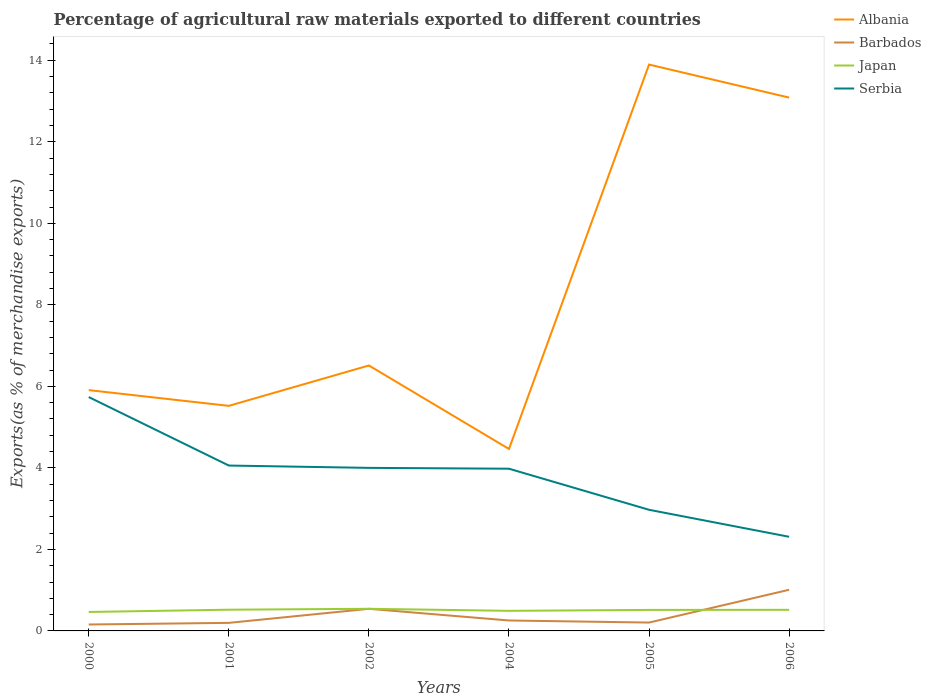Does the line corresponding to Barbados intersect with the line corresponding to Serbia?
Your answer should be compact. No. Is the number of lines equal to the number of legend labels?
Keep it short and to the point. Yes. Across all years, what is the maximum percentage of exports to different countries in Albania?
Provide a succinct answer. 4.46. In which year was the percentage of exports to different countries in Barbados maximum?
Make the answer very short. 2000. What is the total percentage of exports to different countries in Albania in the graph?
Offer a very short reply. -6.57. What is the difference between the highest and the second highest percentage of exports to different countries in Japan?
Your answer should be very brief. 0.08. How many lines are there?
Make the answer very short. 4. Are the values on the major ticks of Y-axis written in scientific E-notation?
Your answer should be compact. No. Does the graph contain any zero values?
Provide a succinct answer. No. Does the graph contain grids?
Provide a short and direct response. No. How are the legend labels stacked?
Provide a succinct answer. Vertical. What is the title of the graph?
Offer a very short reply. Percentage of agricultural raw materials exported to different countries. What is the label or title of the X-axis?
Keep it short and to the point. Years. What is the label or title of the Y-axis?
Make the answer very short. Exports(as % of merchandise exports). What is the Exports(as % of merchandise exports) in Albania in 2000?
Your response must be concise. 5.91. What is the Exports(as % of merchandise exports) in Barbados in 2000?
Keep it short and to the point. 0.16. What is the Exports(as % of merchandise exports) of Japan in 2000?
Ensure brevity in your answer.  0.46. What is the Exports(as % of merchandise exports) of Serbia in 2000?
Keep it short and to the point. 5.74. What is the Exports(as % of merchandise exports) of Albania in 2001?
Your response must be concise. 5.52. What is the Exports(as % of merchandise exports) of Barbados in 2001?
Provide a short and direct response. 0.2. What is the Exports(as % of merchandise exports) of Japan in 2001?
Your answer should be very brief. 0.52. What is the Exports(as % of merchandise exports) of Serbia in 2001?
Offer a terse response. 4.06. What is the Exports(as % of merchandise exports) of Albania in 2002?
Ensure brevity in your answer.  6.51. What is the Exports(as % of merchandise exports) of Barbados in 2002?
Your response must be concise. 0.54. What is the Exports(as % of merchandise exports) of Japan in 2002?
Give a very brief answer. 0.54. What is the Exports(as % of merchandise exports) in Serbia in 2002?
Your answer should be very brief. 4. What is the Exports(as % of merchandise exports) of Albania in 2004?
Keep it short and to the point. 4.46. What is the Exports(as % of merchandise exports) of Barbados in 2004?
Give a very brief answer. 0.26. What is the Exports(as % of merchandise exports) in Japan in 2004?
Offer a terse response. 0.49. What is the Exports(as % of merchandise exports) of Serbia in 2004?
Offer a very short reply. 3.98. What is the Exports(as % of merchandise exports) in Albania in 2005?
Ensure brevity in your answer.  13.89. What is the Exports(as % of merchandise exports) in Barbados in 2005?
Provide a succinct answer. 0.21. What is the Exports(as % of merchandise exports) of Japan in 2005?
Your response must be concise. 0.52. What is the Exports(as % of merchandise exports) of Serbia in 2005?
Your answer should be compact. 2.97. What is the Exports(as % of merchandise exports) of Albania in 2006?
Your answer should be very brief. 13.08. What is the Exports(as % of merchandise exports) of Barbados in 2006?
Your answer should be compact. 1.01. What is the Exports(as % of merchandise exports) of Japan in 2006?
Keep it short and to the point. 0.52. What is the Exports(as % of merchandise exports) of Serbia in 2006?
Give a very brief answer. 2.31. Across all years, what is the maximum Exports(as % of merchandise exports) in Albania?
Provide a succinct answer. 13.89. Across all years, what is the maximum Exports(as % of merchandise exports) of Barbados?
Your answer should be very brief. 1.01. Across all years, what is the maximum Exports(as % of merchandise exports) in Japan?
Your response must be concise. 0.54. Across all years, what is the maximum Exports(as % of merchandise exports) in Serbia?
Your answer should be compact. 5.74. Across all years, what is the minimum Exports(as % of merchandise exports) of Albania?
Keep it short and to the point. 4.46. Across all years, what is the minimum Exports(as % of merchandise exports) in Barbados?
Give a very brief answer. 0.16. Across all years, what is the minimum Exports(as % of merchandise exports) of Japan?
Give a very brief answer. 0.46. Across all years, what is the minimum Exports(as % of merchandise exports) in Serbia?
Your answer should be very brief. 2.31. What is the total Exports(as % of merchandise exports) of Albania in the graph?
Ensure brevity in your answer.  49.38. What is the total Exports(as % of merchandise exports) of Barbados in the graph?
Make the answer very short. 2.37. What is the total Exports(as % of merchandise exports) of Japan in the graph?
Keep it short and to the point. 3.05. What is the total Exports(as % of merchandise exports) of Serbia in the graph?
Offer a terse response. 23.05. What is the difference between the Exports(as % of merchandise exports) of Albania in 2000 and that in 2001?
Provide a short and direct response. 0.39. What is the difference between the Exports(as % of merchandise exports) in Barbados in 2000 and that in 2001?
Your response must be concise. -0.04. What is the difference between the Exports(as % of merchandise exports) of Japan in 2000 and that in 2001?
Your answer should be very brief. -0.06. What is the difference between the Exports(as % of merchandise exports) of Serbia in 2000 and that in 2001?
Offer a terse response. 1.68. What is the difference between the Exports(as % of merchandise exports) of Albania in 2000 and that in 2002?
Your answer should be very brief. -0.6. What is the difference between the Exports(as % of merchandise exports) in Barbados in 2000 and that in 2002?
Give a very brief answer. -0.38. What is the difference between the Exports(as % of merchandise exports) of Japan in 2000 and that in 2002?
Provide a short and direct response. -0.08. What is the difference between the Exports(as % of merchandise exports) of Serbia in 2000 and that in 2002?
Make the answer very short. 1.74. What is the difference between the Exports(as % of merchandise exports) of Albania in 2000 and that in 2004?
Your answer should be compact. 1.44. What is the difference between the Exports(as % of merchandise exports) of Barbados in 2000 and that in 2004?
Your answer should be very brief. -0.1. What is the difference between the Exports(as % of merchandise exports) of Japan in 2000 and that in 2004?
Keep it short and to the point. -0.03. What is the difference between the Exports(as % of merchandise exports) of Serbia in 2000 and that in 2004?
Offer a terse response. 1.76. What is the difference between the Exports(as % of merchandise exports) of Albania in 2000 and that in 2005?
Your answer should be compact. -7.99. What is the difference between the Exports(as % of merchandise exports) in Barbados in 2000 and that in 2005?
Your response must be concise. -0.05. What is the difference between the Exports(as % of merchandise exports) of Japan in 2000 and that in 2005?
Keep it short and to the point. -0.05. What is the difference between the Exports(as % of merchandise exports) of Serbia in 2000 and that in 2005?
Offer a terse response. 2.77. What is the difference between the Exports(as % of merchandise exports) in Albania in 2000 and that in 2006?
Provide a short and direct response. -7.18. What is the difference between the Exports(as % of merchandise exports) of Barbados in 2000 and that in 2006?
Offer a very short reply. -0.85. What is the difference between the Exports(as % of merchandise exports) of Japan in 2000 and that in 2006?
Give a very brief answer. -0.05. What is the difference between the Exports(as % of merchandise exports) in Serbia in 2000 and that in 2006?
Your response must be concise. 3.43. What is the difference between the Exports(as % of merchandise exports) in Albania in 2001 and that in 2002?
Your answer should be compact. -0.99. What is the difference between the Exports(as % of merchandise exports) in Barbados in 2001 and that in 2002?
Make the answer very short. -0.34. What is the difference between the Exports(as % of merchandise exports) in Japan in 2001 and that in 2002?
Your answer should be very brief. -0.02. What is the difference between the Exports(as % of merchandise exports) in Serbia in 2001 and that in 2002?
Provide a succinct answer. 0.06. What is the difference between the Exports(as % of merchandise exports) in Albania in 2001 and that in 2004?
Give a very brief answer. 1.06. What is the difference between the Exports(as % of merchandise exports) of Barbados in 2001 and that in 2004?
Keep it short and to the point. -0.06. What is the difference between the Exports(as % of merchandise exports) in Japan in 2001 and that in 2004?
Your answer should be compact. 0.03. What is the difference between the Exports(as % of merchandise exports) in Serbia in 2001 and that in 2004?
Your answer should be compact. 0.08. What is the difference between the Exports(as % of merchandise exports) of Albania in 2001 and that in 2005?
Provide a succinct answer. -8.37. What is the difference between the Exports(as % of merchandise exports) of Barbados in 2001 and that in 2005?
Give a very brief answer. -0.01. What is the difference between the Exports(as % of merchandise exports) of Japan in 2001 and that in 2005?
Your answer should be compact. 0.01. What is the difference between the Exports(as % of merchandise exports) in Serbia in 2001 and that in 2005?
Ensure brevity in your answer.  1.09. What is the difference between the Exports(as % of merchandise exports) of Albania in 2001 and that in 2006?
Offer a terse response. -7.56. What is the difference between the Exports(as % of merchandise exports) in Barbados in 2001 and that in 2006?
Keep it short and to the point. -0.81. What is the difference between the Exports(as % of merchandise exports) of Japan in 2001 and that in 2006?
Offer a very short reply. 0. What is the difference between the Exports(as % of merchandise exports) in Serbia in 2001 and that in 2006?
Your answer should be very brief. 1.75. What is the difference between the Exports(as % of merchandise exports) in Albania in 2002 and that in 2004?
Give a very brief answer. 2.05. What is the difference between the Exports(as % of merchandise exports) in Barbados in 2002 and that in 2004?
Your answer should be compact. 0.29. What is the difference between the Exports(as % of merchandise exports) of Japan in 2002 and that in 2004?
Offer a very short reply. 0.05. What is the difference between the Exports(as % of merchandise exports) in Serbia in 2002 and that in 2004?
Give a very brief answer. 0.02. What is the difference between the Exports(as % of merchandise exports) in Albania in 2002 and that in 2005?
Your response must be concise. -7.38. What is the difference between the Exports(as % of merchandise exports) of Barbados in 2002 and that in 2005?
Make the answer very short. 0.34. What is the difference between the Exports(as % of merchandise exports) in Japan in 2002 and that in 2005?
Your answer should be compact. 0.03. What is the difference between the Exports(as % of merchandise exports) of Serbia in 2002 and that in 2005?
Your answer should be compact. 1.03. What is the difference between the Exports(as % of merchandise exports) of Albania in 2002 and that in 2006?
Offer a terse response. -6.57. What is the difference between the Exports(as % of merchandise exports) in Barbados in 2002 and that in 2006?
Offer a terse response. -0.47. What is the difference between the Exports(as % of merchandise exports) in Japan in 2002 and that in 2006?
Your answer should be very brief. 0.02. What is the difference between the Exports(as % of merchandise exports) in Serbia in 2002 and that in 2006?
Offer a very short reply. 1.69. What is the difference between the Exports(as % of merchandise exports) in Albania in 2004 and that in 2005?
Give a very brief answer. -9.43. What is the difference between the Exports(as % of merchandise exports) of Barbados in 2004 and that in 2005?
Keep it short and to the point. 0.05. What is the difference between the Exports(as % of merchandise exports) in Japan in 2004 and that in 2005?
Provide a short and direct response. -0.02. What is the difference between the Exports(as % of merchandise exports) in Serbia in 2004 and that in 2005?
Your response must be concise. 1.01. What is the difference between the Exports(as % of merchandise exports) in Albania in 2004 and that in 2006?
Give a very brief answer. -8.62. What is the difference between the Exports(as % of merchandise exports) in Barbados in 2004 and that in 2006?
Give a very brief answer. -0.75. What is the difference between the Exports(as % of merchandise exports) of Japan in 2004 and that in 2006?
Offer a terse response. -0.03. What is the difference between the Exports(as % of merchandise exports) of Serbia in 2004 and that in 2006?
Keep it short and to the point. 1.67. What is the difference between the Exports(as % of merchandise exports) in Albania in 2005 and that in 2006?
Your answer should be compact. 0.81. What is the difference between the Exports(as % of merchandise exports) of Barbados in 2005 and that in 2006?
Ensure brevity in your answer.  -0.8. What is the difference between the Exports(as % of merchandise exports) of Japan in 2005 and that in 2006?
Your answer should be very brief. -0. What is the difference between the Exports(as % of merchandise exports) in Serbia in 2005 and that in 2006?
Your response must be concise. 0.66. What is the difference between the Exports(as % of merchandise exports) in Albania in 2000 and the Exports(as % of merchandise exports) in Barbados in 2001?
Make the answer very short. 5.71. What is the difference between the Exports(as % of merchandise exports) in Albania in 2000 and the Exports(as % of merchandise exports) in Japan in 2001?
Ensure brevity in your answer.  5.39. What is the difference between the Exports(as % of merchandise exports) in Albania in 2000 and the Exports(as % of merchandise exports) in Serbia in 2001?
Your answer should be compact. 1.85. What is the difference between the Exports(as % of merchandise exports) in Barbados in 2000 and the Exports(as % of merchandise exports) in Japan in 2001?
Offer a terse response. -0.36. What is the difference between the Exports(as % of merchandise exports) in Barbados in 2000 and the Exports(as % of merchandise exports) in Serbia in 2001?
Offer a very short reply. -3.9. What is the difference between the Exports(as % of merchandise exports) in Japan in 2000 and the Exports(as % of merchandise exports) in Serbia in 2001?
Your answer should be compact. -3.59. What is the difference between the Exports(as % of merchandise exports) of Albania in 2000 and the Exports(as % of merchandise exports) of Barbados in 2002?
Provide a short and direct response. 5.37. What is the difference between the Exports(as % of merchandise exports) of Albania in 2000 and the Exports(as % of merchandise exports) of Japan in 2002?
Ensure brevity in your answer.  5.36. What is the difference between the Exports(as % of merchandise exports) in Albania in 2000 and the Exports(as % of merchandise exports) in Serbia in 2002?
Ensure brevity in your answer.  1.91. What is the difference between the Exports(as % of merchandise exports) of Barbados in 2000 and the Exports(as % of merchandise exports) of Japan in 2002?
Ensure brevity in your answer.  -0.39. What is the difference between the Exports(as % of merchandise exports) of Barbados in 2000 and the Exports(as % of merchandise exports) of Serbia in 2002?
Offer a very short reply. -3.84. What is the difference between the Exports(as % of merchandise exports) in Japan in 2000 and the Exports(as % of merchandise exports) in Serbia in 2002?
Ensure brevity in your answer.  -3.54. What is the difference between the Exports(as % of merchandise exports) of Albania in 2000 and the Exports(as % of merchandise exports) of Barbados in 2004?
Your response must be concise. 5.65. What is the difference between the Exports(as % of merchandise exports) in Albania in 2000 and the Exports(as % of merchandise exports) in Japan in 2004?
Give a very brief answer. 5.41. What is the difference between the Exports(as % of merchandise exports) of Albania in 2000 and the Exports(as % of merchandise exports) of Serbia in 2004?
Provide a short and direct response. 1.93. What is the difference between the Exports(as % of merchandise exports) of Barbados in 2000 and the Exports(as % of merchandise exports) of Japan in 2004?
Make the answer very short. -0.34. What is the difference between the Exports(as % of merchandise exports) of Barbados in 2000 and the Exports(as % of merchandise exports) of Serbia in 2004?
Keep it short and to the point. -3.82. What is the difference between the Exports(as % of merchandise exports) in Japan in 2000 and the Exports(as % of merchandise exports) in Serbia in 2004?
Your answer should be compact. -3.51. What is the difference between the Exports(as % of merchandise exports) in Albania in 2000 and the Exports(as % of merchandise exports) in Barbados in 2005?
Offer a terse response. 5.7. What is the difference between the Exports(as % of merchandise exports) of Albania in 2000 and the Exports(as % of merchandise exports) of Japan in 2005?
Offer a terse response. 5.39. What is the difference between the Exports(as % of merchandise exports) of Albania in 2000 and the Exports(as % of merchandise exports) of Serbia in 2005?
Your response must be concise. 2.94. What is the difference between the Exports(as % of merchandise exports) in Barbados in 2000 and the Exports(as % of merchandise exports) in Japan in 2005?
Provide a short and direct response. -0.36. What is the difference between the Exports(as % of merchandise exports) of Barbados in 2000 and the Exports(as % of merchandise exports) of Serbia in 2005?
Your answer should be compact. -2.81. What is the difference between the Exports(as % of merchandise exports) in Japan in 2000 and the Exports(as % of merchandise exports) in Serbia in 2005?
Offer a terse response. -2.51. What is the difference between the Exports(as % of merchandise exports) in Albania in 2000 and the Exports(as % of merchandise exports) in Barbados in 2006?
Provide a short and direct response. 4.9. What is the difference between the Exports(as % of merchandise exports) of Albania in 2000 and the Exports(as % of merchandise exports) of Japan in 2006?
Your answer should be compact. 5.39. What is the difference between the Exports(as % of merchandise exports) of Albania in 2000 and the Exports(as % of merchandise exports) of Serbia in 2006?
Offer a very short reply. 3.6. What is the difference between the Exports(as % of merchandise exports) in Barbados in 2000 and the Exports(as % of merchandise exports) in Japan in 2006?
Make the answer very short. -0.36. What is the difference between the Exports(as % of merchandise exports) in Barbados in 2000 and the Exports(as % of merchandise exports) in Serbia in 2006?
Offer a very short reply. -2.15. What is the difference between the Exports(as % of merchandise exports) of Japan in 2000 and the Exports(as % of merchandise exports) of Serbia in 2006?
Keep it short and to the point. -1.84. What is the difference between the Exports(as % of merchandise exports) in Albania in 2001 and the Exports(as % of merchandise exports) in Barbados in 2002?
Your answer should be very brief. 4.98. What is the difference between the Exports(as % of merchandise exports) in Albania in 2001 and the Exports(as % of merchandise exports) in Japan in 2002?
Offer a very short reply. 4.98. What is the difference between the Exports(as % of merchandise exports) of Albania in 2001 and the Exports(as % of merchandise exports) of Serbia in 2002?
Provide a succinct answer. 1.52. What is the difference between the Exports(as % of merchandise exports) of Barbados in 2001 and the Exports(as % of merchandise exports) of Japan in 2002?
Your response must be concise. -0.34. What is the difference between the Exports(as % of merchandise exports) in Barbados in 2001 and the Exports(as % of merchandise exports) in Serbia in 2002?
Your answer should be very brief. -3.8. What is the difference between the Exports(as % of merchandise exports) of Japan in 2001 and the Exports(as % of merchandise exports) of Serbia in 2002?
Your answer should be compact. -3.48. What is the difference between the Exports(as % of merchandise exports) in Albania in 2001 and the Exports(as % of merchandise exports) in Barbados in 2004?
Make the answer very short. 5.27. What is the difference between the Exports(as % of merchandise exports) in Albania in 2001 and the Exports(as % of merchandise exports) in Japan in 2004?
Your response must be concise. 5.03. What is the difference between the Exports(as % of merchandise exports) of Albania in 2001 and the Exports(as % of merchandise exports) of Serbia in 2004?
Offer a very short reply. 1.54. What is the difference between the Exports(as % of merchandise exports) of Barbados in 2001 and the Exports(as % of merchandise exports) of Japan in 2004?
Offer a terse response. -0.3. What is the difference between the Exports(as % of merchandise exports) of Barbados in 2001 and the Exports(as % of merchandise exports) of Serbia in 2004?
Provide a short and direct response. -3.78. What is the difference between the Exports(as % of merchandise exports) of Japan in 2001 and the Exports(as % of merchandise exports) of Serbia in 2004?
Provide a succinct answer. -3.46. What is the difference between the Exports(as % of merchandise exports) in Albania in 2001 and the Exports(as % of merchandise exports) in Barbados in 2005?
Offer a terse response. 5.32. What is the difference between the Exports(as % of merchandise exports) of Albania in 2001 and the Exports(as % of merchandise exports) of Japan in 2005?
Provide a short and direct response. 5.01. What is the difference between the Exports(as % of merchandise exports) in Albania in 2001 and the Exports(as % of merchandise exports) in Serbia in 2005?
Your answer should be compact. 2.55. What is the difference between the Exports(as % of merchandise exports) of Barbados in 2001 and the Exports(as % of merchandise exports) of Japan in 2005?
Your answer should be compact. -0.32. What is the difference between the Exports(as % of merchandise exports) in Barbados in 2001 and the Exports(as % of merchandise exports) in Serbia in 2005?
Keep it short and to the point. -2.77. What is the difference between the Exports(as % of merchandise exports) of Japan in 2001 and the Exports(as % of merchandise exports) of Serbia in 2005?
Provide a short and direct response. -2.45. What is the difference between the Exports(as % of merchandise exports) of Albania in 2001 and the Exports(as % of merchandise exports) of Barbados in 2006?
Provide a succinct answer. 4.51. What is the difference between the Exports(as % of merchandise exports) of Albania in 2001 and the Exports(as % of merchandise exports) of Japan in 2006?
Keep it short and to the point. 5. What is the difference between the Exports(as % of merchandise exports) in Albania in 2001 and the Exports(as % of merchandise exports) in Serbia in 2006?
Offer a very short reply. 3.21. What is the difference between the Exports(as % of merchandise exports) in Barbados in 2001 and the Exports(as % of merchandise exports) in Japan in 2006?
Offer a very short reply. -0.32. What is the difference between the Exports(as % of merchandise exports) in Barbados in 2001 and the Exports(as % of merchandise exports) in Serbia in 2006?
Your answer should be compact. -2.11. What is the difference between the Exports(as % of merchandise exports) in Japan in 2001 and the Exports(as % of merchandise exports) in Serbia in 2006?
Offer a terse response. -1.79. What is the difference between the Exports(as % of merchandise exports) of Albania in 2002 and the Exports(as % of merchandise exports) of Barbados in 2004?
Keep it short and to the point. 6.26. What is the difference between the Exports(as % of merchandise exports) in Albania in 2002 and the Exports(as % of merchandise exports) in Japan in 2004?
Your response must be concise. 6.02. What is the difference between the Exports(as % of merchandise exports) in Albania in 2002 and the Exports(as % of merchandise exports) in Serbia in 2004?
Offer a very short reply. 2.53. What is the difference between the Exports(as % of merchandise exports) in Barbados in 2002 and the Exports(as % of merchandise exports) in Japan in 2004?
Provide a short and direct response. 0.05. What is the difference between the Exports(as % of merchandise exports) in Barbados in 2002 and the Exports(as % of merchandise exports) in Serbia in 2004?
Provide a short and direct response. -3.44. What is the difference between the Exports(as % of merchandise exports) in Japan in 2002 and the Exports(as % of merchandise exports) in Serbia in 2004?
Provide a succinct answer. -3.44. What is the difference between the Exports(as % of merchandise exports) of Albania in 2002 and the Exports(as % of merchandise exports) of Barbados in 2005?
Provide a succinct answer. 6.31. What is the difference between the Exports(as % of merchandise exports) in Albania in 2002 and the Exports(as % of merchandise exports) in Japan in 2005?
Make the answer very short. 6. What is the difference between the Exports(as % of merchandise exports) of Albania in 2002 and the Exports(as % of merchandise exports) of Serbia in 2005?
Your answer should be very brief. 3.54. What is the difference between the Exports(as % of merchandise exports) of Barbados in 2002 and the Exports(as % of merchandise exports) of Japan in 2005?
Your answer should be compact. 0.03. What is the difference between the Exports(as % of merchandise exports) in Barbados in 2002 and the Exports(as % of merchandise exports) in Serbia in 2005?
Offer a terse response. -2.43. What is the difference between the Exports(as % of merchandise exports) in Japan in 2002 and the Exports(as % of merchandise exports) in Serbia in 2005?
Your response must be concise. -2.43. What is the difference between the Exports(as % of merchandise exports) in Albania in 2002 and the Exports(as % of merchandise exports) in Barbados in 2006?
Provide a short and direct response. 5.5. What is the difference between the Exports(as % of merchandise exports) in Albania in 2002 and the Exports(as % of merchandise exports) in Japan in 2006?
Offer a terse response. 5.99. What is the difference between the Exports(as % of merchandise exports) of Albania in 2002 and the Exports(as % of merchandise exports) of Serbia in 2006?
Offer a very short reply. 4.2. What is the difference between the Exports(as % of merchandise exports) of Barbados in 2002 and the Exports(as % of merchandise exports) of Japan in 2006?
Provide a succinct answer. 0.02. What is the difference between the Exports(as % of merchandise exports) of Barbados in 2002 and the Exports(as % of merchandise exports) of Serbia in 2006?
Give a very brief answer. -1.77. What is the difference between the Exports(as % of merchandise exports) in Japan in 2002 and the Exports(as % of merchandise exports) in Serbia in 2006?
Your response must be concise. -1.77. What is the difference between the Exports(as % of merchandise exports) in Albania in 2004 and the Exports(as % of merchandise exports) in Barbados in 2005?
Your answer should be very brief. 4.26. What is the difference between the Exports(as % of merchandise exports) of Albania in 2004 and the Exports(as % of merchandise exports) of Japan in 2005?
Provide a short and direct response. 3.95. What is the difference between the Exports(as % of merchandise exports) of Albania in 2004 and the Exports(as % of merchandise exports) of Serbia in 2005?
Offer a very short reply. 1.49. What is the difference between the Exports(as % of merchandise exports) in Barbados in 2004 and the Exports(as % of merchandise exports) in Japan in 2005?
Ensure brevity in your answer.  -0.26. What is the difference between the Exports(as % of merchandise exports) in Barbados in 2004 and the Exports(as % of merchandise exports) in Serbia in 2005?
Your answer should be compact. -2.72. What is the difference between the Exports(as % of merchandise exports) of Japan in 2004 and the Exports(as % of merchandise exports) of Serbia in 2005?
Offer a very short reply. -2.48. What is the difference between the Exports(as % of merchandise exports) of Albania in 2004 and the Exports(as % of merchandise exports) of Barbados in 2006?
Ensure brevity in your answer.  3.45. What is the difference between the Exports(as % of merchandise exports) of Albania in 2004 and the Exports(as % of merchandise exports) of Japan in 2006?
Provide a succinct answer. 3.95. What is the difference between the Exports(as % of merchandise exports) in Albania in 2004 and the Exports(as % of merchandise exports) in Serbia in 2006?
Give a very brief answer. 2.15. What is the difference between the Exports(as % of merchandise exports) of Barbados in 2004 and the Exports(as % of merchandise exports) of Japan in 2006?
Your answer should be compact. -0.26. What is the difference between the Exports(as % of merchandise exports) in Barbados in 2004 and the Exports(as % of merchandise exports) in Serbia in 2006?
Provide a short and direct response. -2.05. What is the difference between the Exports(as % of merchandise exports) of Japan in 2004 and the Exports(as % of merchandise exports) of Serbia in 2006?
Ensure brevity in your answer.  -1.82. What is the difference between the Exports(as % of merchandise exports) of Albania in 2005 and the Exports(as % of merchandise exports) of Barbados in 2006?
Offer a terse response. 12.88. What is the difference between the Exports(as % of merchandise exports) of Albania in 2005 and the Exports(as % of merchandise exports) of Japan in 2006?
Make the answer very short. 13.38. What is the difference between the Exports(as % of merchandise exports) of Albania in 2005 and the Exports(as % of merchandise exports) of Serbia in 2006?
Provide a short and direct response. 11.58. What is the difference between the Exports(as % of merchandise exports) of Barbados in 2005 and the Exports(as % of merchandise exports) of Japan in 2006?
Keep it short and to the point. -0.31. What is the difference between the Exports(as % of merchandise exports) of Barbados in 2005 and the Exports(as % of merchandise exports) of Serbia in 2006?
Keep it short and to the point. -2.1. What is the difference between the Exports(as % of merchandise exports) of Japan in 2005 and the Exports(as % of merchandise exports) of Serbia in 2006?
Ensure brevity in your answer.  -1.79. What is the average Exports(as % of merchandise exports) in Albania per year?
Make the answer very short. 8.23. What is the average Exports(as % of merchandise exports) of Barbados per year?
Give a very brief answer. 0.39. What is the average Exports(as % of merchandise exports) of Japan per year?
Your response must be concise. 0.51. What is the average Exports(as % of merchandise exports) of Serbia per year?
Give a very brief answer. 3.84. In the year 2000, what is the difference between the Exports(as % of merchandise exports) in Albania and Exports(as % of merchandise exports) in Barbados?
Your answer should be compact. 5.75. In the year 2000, what is the difference between the Exports(as % of merchandise exports) in Albania and Exports(as % of merchandise exports) in Japan?
Make the answer very short. 5.44. In the year 2000, what is the difference between the Exports(as % of merchandise exports) in Albania and Exports(as % of merchandise exports) in Serbia?
Provide a succinct answer. 0.17. In the year 2000, what is the difference between the Exports(as % of merchandise exports) in Barbados and Exports(as % of merchandise exports) in Japan?
Your response must be concise. -0.31. In the year 2000, what is the difference between the Exports(as % of merchandise exports) in Barbados and Exports(as % of merchandise exports) in Serbia?
Provide a succinct answer. -5.58. In the year 2000, what is the difference between the Exports(as % of merchandise exports) in Japan and Exports(as % of merchandise exports) in Serbia?
Make the answer very short. -5.27. In the year 2001, what is the difference between the Exports(as % of merchandise exports) in Albania and Exports(as % of merchandise exports) in Barbados?
Provide a short and direct response. 5.32. In the year 2001, what is the difference between the Exports(as % of merchandise exports) of Albania and Exports(as % of merchandise exports) of Japan?
Your response must be concise. 5. In the year 2001, what is the difference between the Exports(as % of merchandise exports) in Albania and Exports(as % of merchandise exports) in Serbia?
Offer a terse response. 1.46. In the year 2001, what is the difference between the Exports(as % of merchandise exports) in Barbados and Exports(as % of merchandise exports) in Japan?
Offer a very short reply. -0.32. In the year 2001, what is the difference between the Exports(as % of merchandise exports) of Barbados and Exports(as % of merchandise exports) of Serbia?
Your response must be concise. -3.86. In the year 2001, what is the difference between the Exports(as % of merchandise exports) in Japan and Exports(as % of merchandise exports) in Serbia?
Ensure brevity in your answer.  -3.54. In the year 2002, what is the difference between the Exports(as % of merchandise exports) of Albania and Exports(as % of merchandise exports) of Barbados?
Ensure brevity in your answer.  5.97. In the year 2002, what is the difference between the Exports(as % of merchandise exports) of Albania and Exports(as % of merchandise exports) of Japan?
Offer a very short reply. 5.97. In the year 2002, what is the difference between the Exports(as % of merchandise exports) in Albania and Exports(as % of merchandise exports) in Serbia?
Ensure brevity in your answer.  2.51. In the year 2002, what is the difference between the Exports(as % of merchandise exports) of Barbados and Exports(as % of merchandise exports) of Japan?
Provide a succinct answer. -0. In the year 2002, what is the difference between the Exports(as % of merchandise exports) in Barbados and Exports(as % of merchandise exports) in Serbia?
Offer a very short reply. -3.46. In the year 2002, what is the difference between the Exports(as % of merchandise exports) in Japan and Exports(as % of merchandise exports) in Serbia?
Your answer should be compact. -3.46. In the year 2004, what is the difference between the Exports(as % of merchandise exports) in Albania and Exports(as % of merchandise exports) in Barbados?
Offer a very short reply. 4.21. In the year 2004, what is the difference between the Exports(as % of merchandise exports) in Albania and Exports(as % of merchandise exports) in Japan?
Ensure brevity in your answer.  3.97. In the year 2004, what is the difference between the Exports(as % of merchandise exports) of Albania and Exports(as % of merchandise exports) of Serbia?
Provide a succinct answer. 0.48. In the year 2004, what is the difference between the Exports(as % of merchandise exports) in Barbados and Exports(as % of merchandise exports) in Japan?
Ensure brevity in your answer.  -0.24. In the year 2004, what is the difference between the Exports(as % of merchandise exports) of Barbados and Exports(as % of merchandise exports) of Serbia?
Provide a succinct answer. -3.72. In the year 2004, what is the difference between the Exports(as % of merchandise exports) in Japan and Exports(as % of merchandise exports) in Serbia?
Provide a succinct answer. -3.49. In the year 2005, what is the difference between the Exports(as % of merchandise exports) in Albania and Exports(as % of merchandise exports) in Barbados?
Offer a terse response. 13.69. In the year 2005, what is the difference between the Exports(as % of merchandise exports) in Albania and Exports(as % of merchandise exports) in Japan?
Your response must be concise. 13.38. In the year 2005, what is the difference between the Exports(as % of merchandise exports) of Albania and Exports(as % of merchandise exports) of Serbia?
Your answer should be very brief. 10.92. In the year 2005, what is the difference between the Exports(as % of merchandise exports) of Barbados and Exports(as % of merchandise exports) of Japan?
Ensure brevity in your answer.  -0.31. In the year 2005, what is the difference between the Exports(as % of merchandise exports) in Barbados and Exports(as % of merchandise exports) in Serbia?
Provide a short and direct response. -2.77. In the year 2005, what is the difference between the Exports(as % of merchandise exports) in Japan and Exports(as % of merchandise exports) in Serbia?
Your answer should be compact. -2.46. In the year 2006, what is the difference between the Exports(as % of merchandise exports) in Albania and Exports(as % of merchandise exports) in Barbados?
Make the answer very short. 12.07. In the year 2006, what is the difference between the Exports(as % of merchandise exports) in Albania and Exports(as % of merchandise exports) in Japan?
Offer a very short reply. 12.57. In the year 2006, what is the difference between the Exports(as % of merchandise exports) of Albania and Exports(as % of merchandise exports) of Serbia?
Provide a succinct answer. 10.77. In the year 2006, what is the difference between the Exports(as % of merchandise exports) of Barbados and Exports(as % of merchandise exports) of Japan?
Your answer should be very brief. 0.49. In the year 2006, what is the difference between the Exports(as % of merchandise exports) in Barbados and Exports(as % of merchandise exports) in Serbia?
Provide a short and direct response. -1.3. In the year 2006, what is the difference between the Exports(as % of merchandise exports) of Japan and Exports(as % of merchandise exports) of Serbia?
Provide a succinct answer. -1.79. What is the ratio of the Exports(as % of merchandise exports) of Albania in 2000 to that in 2001?
Make the answer very short. 1.07. What is the ratio of the Exports(as % of merchandise exports) in Barbados in 2000 to that in 2001?
Offer a very short reply. 0.8. What is the ratio of the Exports(as % of merchandise exports) in Japan in 2000 to that in 2001?
Your answer should be compact. 0.89. What is the ratio of the Exports(as % of merchandise exports) of Serbia in 2000 to that in 2001?
Provide a short and direct response. 1.41. What is the ratio of the Exports(as % of merchandise exports) in Albania in 2000 to that in 2002?
Provide a short and direct response. 0.91. What is the ratio of the Exports(as % of merchandise exports) in Barbados in 2000 to that in 2002?
Your answer should be very brief. 0.29. What is the ratio of the Exports(as % of merchandise exports) of Japan in 2000 to that in 2002?
Ensure brevity in your answer.  0.86. What is the ratio of the Exports(as % of merchandise exports) in Serbia in 2000 to that in 2002?
Make the answer very short. 1.43. What is the ratio of the Exports(as % of merchandise exports) of Albania in 2000 to that in 2004?
Give a very brief answer. 1.32. What is the ratio of the Exports(as % of merchandise exports) in Barbados in 2000 to that in 2004?
Give a very brief answer. 0.61. What is the ratio of the Exports(as % of merchandise exports) of Japan in 2000 to that in 2004?
Keep it short and to the point. 0.94. What is the ratio of the Exports(as % of merchandise exports) in Serbia in 2000 to that in 2004?
Give a very brief answer. 1.44. What is the ratio of the Exports(as % of merchandise exports) in Albania in 2000 to that in 2005?
Offer a very short reply. 0.43. What is the ratio of the Exports(as % of merchandise exports) in Barbados in 2000 to that in 2005?
Provide a succinct answer. 0.77. What is the ratio of the Exports(as % of merchandise exports) in Japan in 2000 to that in 2005?
Offer a very short reply. 0.9. What is the ratio of the Exports(as % of merchandise exports) of Serbia in 2000 to that in 2005?
Keep it short and to the point. 1.93. What is the ratio of the Exports(as % of merchandise exports) in Albania in 2000 to that in 2006?
Make the answer very short. 0.45. What is the ratio of the Exports(as % of merchandise exports) of Barbados in 2000 to that in 2006?
Your answer should be very brief. 0.16. What is the ratio of the Exports(as % of merchandise exports) in Japan in 2000 to that in 2006?
Provide a short and direct response. 0.9. What is the ratio of the Exports(as % of merchandise exports) of Serbia in 2000 to that in 2006?
Offer a very short reply. 2.48. What is the ratio of the Exports(as % of merchandise exports) of Albania in 2001 to that in 2002?
Keep it short and to the point. 0.85. What is the ratio of the Exports(as % of merchandise exports) in Barbados in 2001 to that in 2002?
Ensure brevity in your answer.  0.36. What is the ratio of the Exports(as % of merchandise exports) of Japan in 2001 to that in 2002?
Keep it short and to the point. 0.96. What is the ratio of the Exports(as % of merchandise exports) in Serbia in 2001 to that in 2002?
Keep it short and to the point. 1.01. What is the ratio of the Exports(as % of merchandise exports) in Albania in 2001 to that in 2004?
Give a very brief answer. 1.24. What is the ratio of the Exports(as % of merchandise exports) in Barbados in 2001 to that in 2004?
Provide a short and direct response. 0.77. What is the ratio of the Exports(as % of merchandise exports) of Japan in 2001 to that in 2004?
Offer a very short reply. 1.06. What is the ratio of the Exports(as % of merchandise exports) of Serbia in 2001 to that in 2004?
Make the answer very short. 1.02. What is the ratio of the Exports(as % of merchandise exports) of Albania in 2001 to that in 2005?
Provide a short and direct response. 0.4. What is the ratio of the Exports(as % of merchandise exports) in Barbados in 2001 to that in 2005?
Keep it short and to the point. 0.96. What is the ratio of the Exports(as % of merchandise exports) in Japan in 2001 to that in 2005?
Ensure brevity in your answer.  1.01. What is the ratio of the Exports(as % of merchandise exports) in Serbia in 2001 to that in 2005?
Your answer should be very brief. 1.37. What is the ratio of the Exports(as % of merchandise exports) of Albania in 2001 to that in 2006?
Give a very brief answer. 0.42. What is the ratio of the Exports(as % of merchandise exports) of Barbados in 2001 to that in 2006?
Provide a short and direct response. 0.2. What is the ratio of the Exports(as % of merchandise exports) in Japan in 2001 to that in 2006?
Make the answer very short. 1. What is the ratio of the Exports(as % of merchandise exports) of Serbia in 2001 to that in 2006?
Make the answer very short. 1.76. What is the ratio of the Exports(as % of merchandise exports) of Albania in 2002 to that in 2004?
Offer a very short reply. 1.46. What is the ratio of the Exports(as % of merchandise exports) of Barbados in 2002 to that in 2004?
Provide a short and direct response. 2.12. What is the ratio of the Exports(as % of merchandise exports) of Japan in 2002 to that in 2004?
Your response must be concise. 1.1. What is the ratio of the Exports(as % of merchandise exports) in Albania in 2002 to that in 2005?
Keep it short and to the point. 0.47. What is the ratio of the Exports(as % of merchandise exports) of Barbados in 2002 to that in 2005?
Ensure brevity in your answer.  2.64. What is the ratio of the Exports(as % of merchandise exports) of Japan in 2002 to that in 2005?
Ensure brevity in your answer.  1.05. What is the ratio of the Exports(as % of merchandise exports) of Serbia in 2002 to that in 2005?
Your answer should be very brief. 1.35. What is the ratio of the Exports(as % of merchandise exports) of Albania in 2002 to that in 2006?
Your response must be concise. 0.5. What is the ratio of the Exports(as % of merchandise exports) in Barbados in 2002 to that in 2006?
Your answer should be compact. 0.54. What is the ratio of the Exports(as % of merchandise exports) of Japan in 2002 to that in 2006?
Ensure brevity in your answer.  1.05. What is the ratio of the Exports(as % of merchandise exports) in Serbia in 2002 to that in 2006?
Keep it short and to the point. 1.73. What is the ratio of the Exports(as % of merchandise exports) of Albania in 2004 to that in 2005?
Provide a short and direct response. 0.32. What is the ratio of the Exports(as % of merchandise exports) of Barbados in 2004 to that in 2005?
Provide a succinct answer. 1.25. What is the ratio of the Exports(as % of merchandise exports) of Japan in 2004 to that in 2005?
Keep it short and to the point. 0.96. What is the ratio of the Exports(as % of merchandise exports) of Serbia in 2004 to that in 2005?
Your answer should be very brief. 1.34. What is the ratio of the Exports(as % of merchandise exports) in Albania in 2004 to that in 2006?
Make the answer very short. 0.34. What is the ratio of the Exports(as % of merchandise exports) of Barbados in 2004 to that in 2006?
Provide a succinct answer. 0.25. What is the ratio of the Exports(as % of merchandise exports) of Japan in 2004 to that in 2006?
Offer a terse response. 0.95. What is the ratio of the Exports(as % of merchandise exports) of Serbia in 2004 to that in 2006?
Provide a short and direct response. 1.72. What is the ratio of the Exports(as % of merchandise exports) of Albania in 2005 to that in 2006?
Your answer should be compact. 1.06. What is the ratio of the Exports(as % of merchandise exports) in Barbados in 2005 to that in 2006?
Your answer should be very brief. 0.2. What is the ratio of the Exports(as % of merchandise exports) in Japan in 2005 to that in 2006?
Make the answer very short. 0.99. What is the ratio of the Exports(as % of merchandise exports) in Serbia in 2005 to that in 2006?
Keep it short and to the point. 1.29. What is the difference between the highest and the second highest Exports(as % of merchandise exports) in Albania?
Ensure brevity in your answer.  0.81. What is the difference between the highest and the second highest Exports(as % of merchandise exports) of Barbados?
Your response must be concise. 0.47. What is the difference between the highest and the second highest Exports(as % of merchandise exports) in Japan?
Your response must be concise. 0.02. What is the difference between the highest and the second highest Exports(as % of merchandise exports) in Serbia?
Your answer should be compact. 1.68. What is the difference between the highest and the lowest Exports(as % of merchandise exports) of Albania?
Offer a terse response. 9.43. What is the difference between the highest and the lowest Exports(as % of merchandise exports) of Barbados?
Your response must be concise. 0.85. What is the difference between the highest and the lowest Exports(as % of merchandise exports) in Japan?
Give a very brief answer. 0.08. What is the difference between the highest and the lowest Exports(as % of merchandise exports) in Serbia?
Provide a succinct answer. 3.43. 